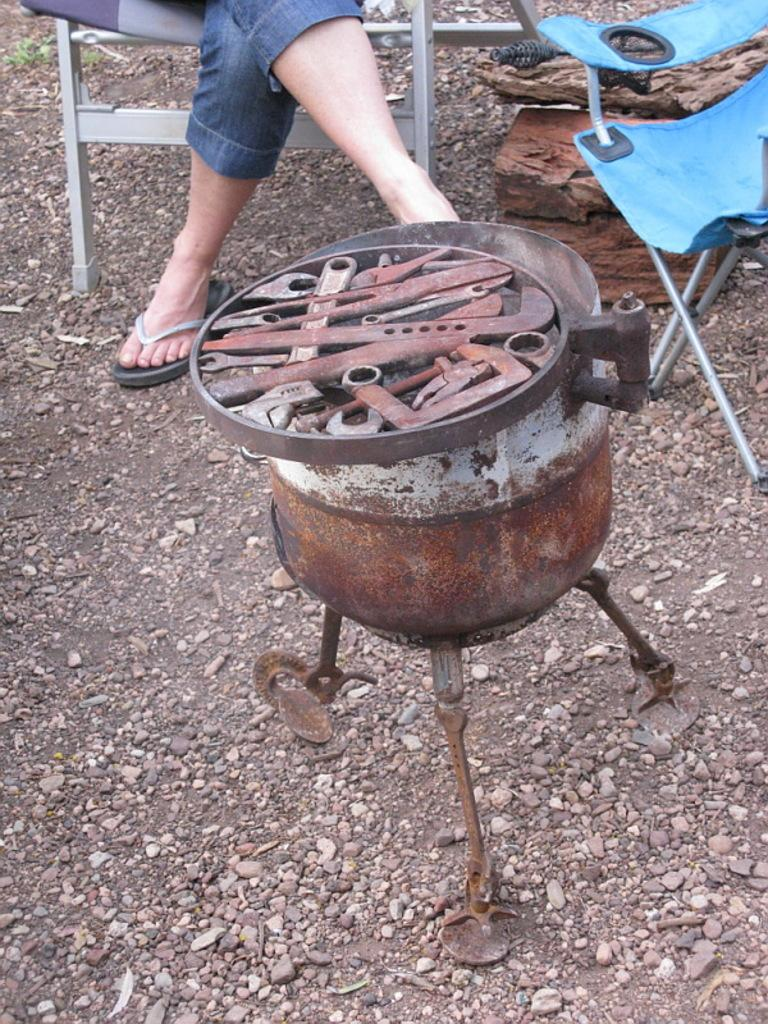What is located in the front of the image? There is an iron stand in the front of the image. What can be seen in the background of the image? There is an empty chair and a person sitting on a chair in the background of the image. What is on the ground in the image? There are stones on the ground in the image. Where is the toothbrush located in the image? There is no toothbrush present in the image. What type of straw is being used by the person sitting on the chair in the image? There is no straw present in the image; the person is sitting on a chair with no visible objects in their hands. 